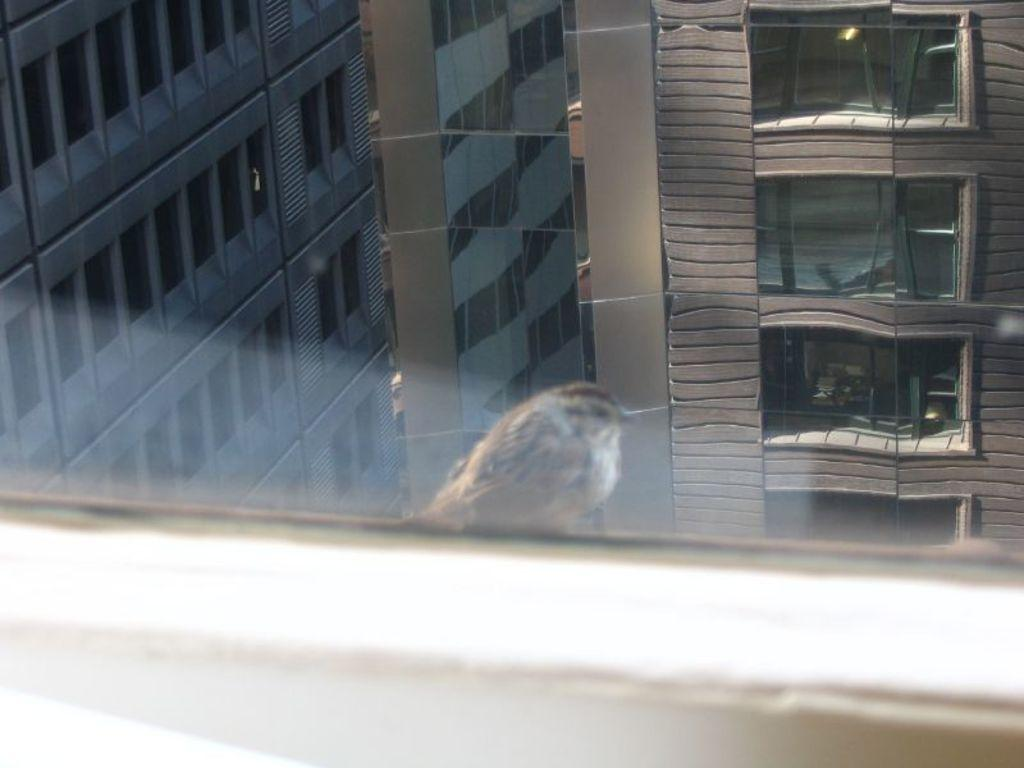What type of animal can be seen in the image? There is a bird in the image. What structures are visible in the background of the image? There are buildings visible in the image. What type of architectural feature is present in the image? There is a glass window in the image. Where is the drawer located in the image? There is no drawer present in the image. What type of planes can be seen flying in the image? There are no planes visible in the image; it only features a bird and buildings. 